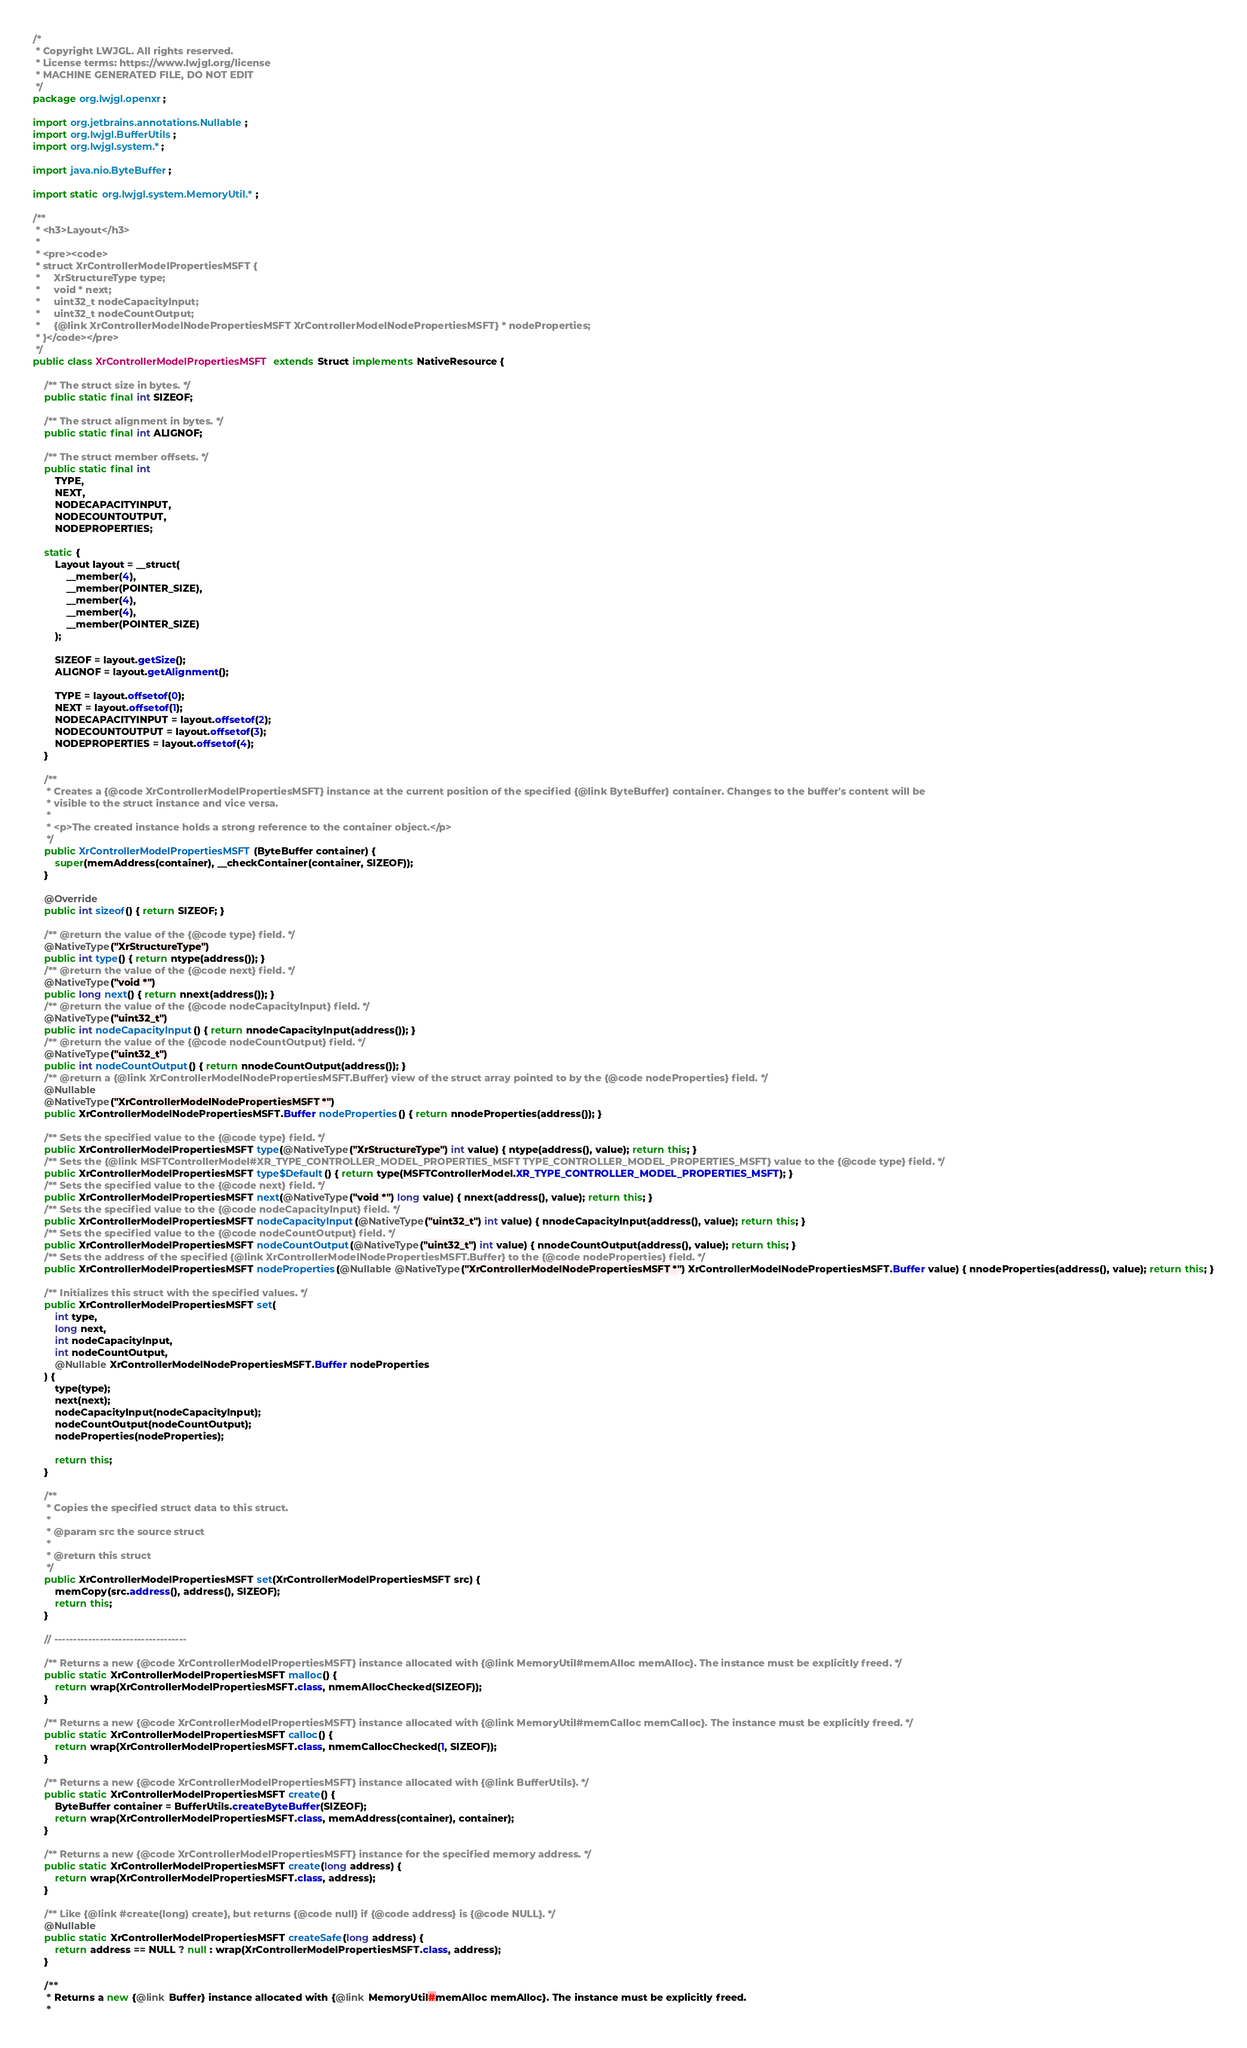Convert code to text. <code><loc_0><loc_0><loc_500><loc_500><_Java_>/*
 * Copyright LWJGL. All rights reserved.
 * License terms: https://www.lwjgl.org/license
 * MACHINE GENERATED FILE, DO NOT EDIT
 */
package org.lwjgl.openxr;

import org.jetbrains.annotations.Nullable;
import org.lwjgl.BufferUtils;
import org.lwjgl.system.*;

import java.nio.ByteBuffer;

import static org.lwjgl.system.MemoryUtil.*;

/**
 * <h3>Layout</h3>
 * 
 * <pre><code>
 * struct XrControllerModelPropertiesMSFT {
 *     XrStructureType type;
 *     void * next;
 *     uint32_t nodeCapacityInput;
 *     uint32_t nodeCountOutput;
 *     {@link XrControllerModelNodePropertiesMSFT XrControllerModelNodePropertiesMSFT} * nodeProperties;
 * }</code></pre>
 */
public class XrControllerModelPropertiesMSFT extends Struct implements NativeResource {

    /** The struct size in bytes. */
    public static final int SIZEOF;

    /** The struct alignment in bytes. */
    public static final int ALIGNOF;

    /** The struct member offsets. */
    public static final int
        TYPE,
        NEXT,
        NODECAPACITYINPUT,
        NODECOUNTOUTPUT,
        NODEPROPERTIES;

    static {
        Layout layout = __struct(
            __member(4),
            __member(POINTER_SIZE),
            __member(4),
            __member(4),
            __member(POINTER_SIZE)
        );

        SIZEOF = layout.getSize();
        ALIGNOF = layout.getAlignment();

        TYPE = layout.offsetof(0);
        NEXT = layout.offsetof(1);
        NODECAPACITYINPUT = layout.offsetof(2);
        NODECOUNTOUTPUT = layout.offsetof(3);
        NODEPROPERTIES = layout.offsetof(4);
    }

    /**
     * Creates a {@code XrControllerModelPropertiesMSFT} instance at the current position of the specified {@link ByteBuffer} container. Changes to the buffer's content will be
     * visible to the struct instance and vice versa.
     *
     * <p>The created instance holds a strong reference to the container object.</p>
     */
    public XrControllerModelPropertiesMSFT(ByteBuffer container) {
        super(memAddress(container), __checkContainer(container, SIZEOF));
    }

    @Override
    public int sizeof() { return SIZEOF; }

    /** @return the value of the {@code type} field. */
    @NativeType("XrStructureType")
    public int type() { return ntype(address()); }
    /** @return the value of the {@code next} field. */
    @NativeType("void *")
    public long next() { return nnext(address()); }
    /** @return the value of the {@code nodeCapacityInput} field. */
    @NativeType("uint32_t")
    public int nodeCapacityInput() { return nnodeCapacityInput(address()); }
    /** @return the value of the {@code nodeCountOutput} field. */
    @NativeType("uint32_t")
    public int nodeCountOutput() { return nnodeCountOutput(address()); }
    /** @return a {@link XrControllerModelNodePropertiesMSFT.Buffer} view of the struct array pointed to by the {@code nodeProperties} field. */
    @Nullable
    @NativeType("XrControllerModelNodePropertiesMSFT *")
    public XrControllerModelNodePropertiesMSFT.Buffer nodeProperties() { return nnodeProperties(address()); }

    /** Sets the specified value to the {@code type} field. */
    public XrControllerModelPropertiesMSFT type(@NativeType("XrStructureType") int value) { ntype(address(), value); return this; }
    /** Sets the {@link MSFTControllerModel#XR_TYPE_CONTROLLER_MODEL_PROPERTIES_MSFT TYPE_CONTROLLER_MODEL_PROPERTIES_MSFT} value to the {@code type} field. */
    public XrControllerModelPropertiesMSFT type$Default() { return type(MSFTControllerModel.XR_TYPE_CONTROLLER_MODEL_PROPERTIES_MSFT); }
    /** Sets the specified value to the {@code next} field. */
    public XrControllerModelPropertiesMSFT next(@NativeType("void *") long value) { nnext(address(), value); return this; }
    /** Sets the specified value to the {@code nodeCapacityInput} field. */
    public XrControllerModelPropertiesMSFT nodeCapacityInput(@NativeType("uint32_t") int value) { nnodeCapacityInput(address(), value); return this; }
    /** Sets the specified value to the {@code nodeCountOutput} field. */
    public XrControllerModelPropertiesMSFT nodeCountOutput(@NativeType("uint32_t") int value) { nnodeCountOutput(address(), value); return this; }
    /** Sets the address of the specified {@link XrControllerModelNodePropertiesMSFT.Buffer} to the {@code nodeProperties} field. */
    public XrControllerModelPropertiesMSFT nodeProperties(@Nullable @NativeType("XrControllerModelNodePropertiesMSFT *") XrControllerModelNodePropertiesMSFT.Buffer value) { nnodeProperties(address(), value); return this; }

    /** Initializes this struct with the specified values. */
    public XrControllerModelPropertiesMSFT set(
        int type,
        long next,
        int nodeCapacityInput,
        int nodeCountOutput,
        @Nullable XrControllerModelNodePropertiesMSFT.Buffer nodeProperties
    ) {
        type(type);
        next(next);
        nodeCapacityInput(nodeCapacityInput);
        nodeCountOutput(nodeCountOutput);
        nodeProperties(nodeProperties);

        return this;
    }

    /**
     * Copies the specified struct data to this struct.
     *
     * @param src the source struct
     *
     * @return this struct
     */
    public XrControllerModelPropertiesMSFT set(XrControllerModelPropertiesMSFT src) {
        memCopy(src.address(), address(), SIZEOF);
        return this;
    }

    // -----------------------------------

    /** Returns a new {@code XrControllerModelPropertiesMSFT} instance allocated with {@link MemoryUtil#memAlloc memAlloc}. The instance must be explicitly freed. */
    public static XrControllerModelPropertiesMSFT malloc() {
        return wrap(XrControllerModelPropertiesMSFT.class, nmemAllocChecked(SIZEOF));
    }

    /** Returns a new {@code XrControllerModelPropertiesMSFT} instance allocated with {@link MemoryUtil#memCalloc memCalloc}. The instance must be explicitly freed. */
    public static XrControllerModelPropertiesMSFT calloc() {
        return wrap(XrControllerModelPropertiesMSFT.class, nmemCallocChecked(1, SIZEOF));
    }

    /** Returns a new {@code XrControllerModelPropertiesMSFT} instance allocated with {@link BufferUtils}. */
    public static XrControllerModelPropertiesMSFT create() {
        ByteBuffer container = BufferUtils.createByteBuffer(SIZEOF);
        return wrap(XrControllerModelPropertiesMSFT.class, memAddress(container), container);
    }

    /** Returns a new {@code XrControllerModelPropertiesMSFT} instance for the specified memory address. */
    public static XrControllerModelPropertiesMSFT create(long address) {
        return wrap(XrControllerModelPropertiesMSFT.class, address);
    }

    /** Like {@link #create(long) create}, but returns {@code null} if {@code address} is {@code NULL}. */
    @Nullable
    public static XrControllerModelPropertiesMSFT createSafe(long address) {
        return address == NULL ? null : wrap(XrControllerModelPropertiesMSFT.class, address);
    }

    /**
     * Returns a new {@link Buffer} instance allocated with {@link MemoryUtil#memAlloc memAlloc}. The instance must be explicitly freed.
     *</code> 